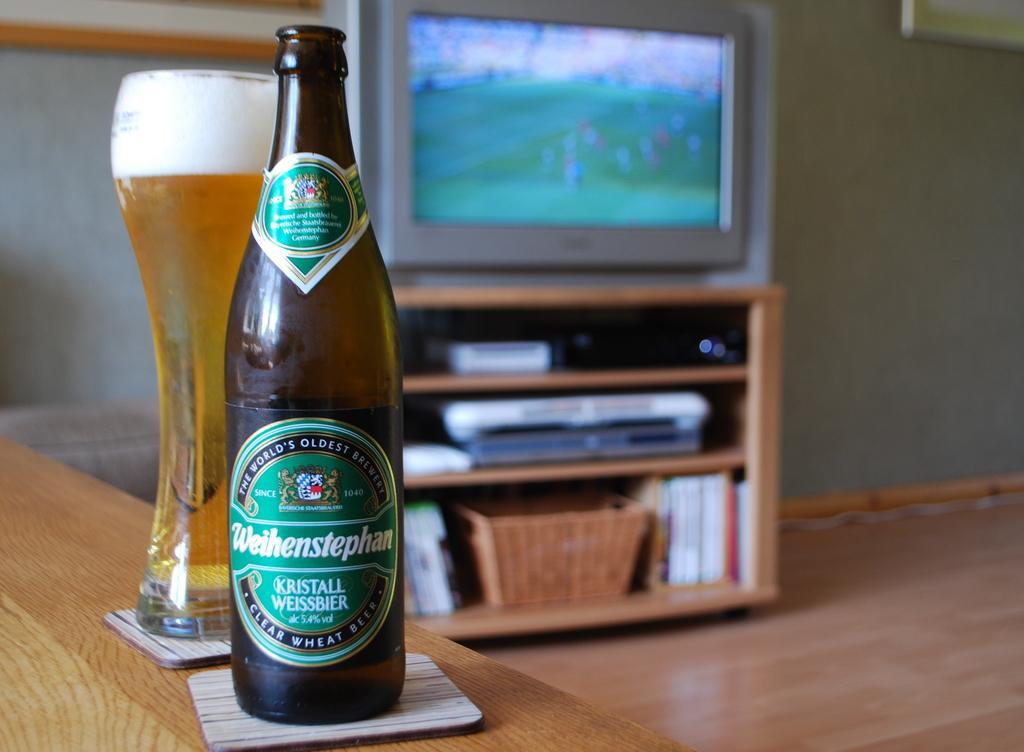<image>
Provide a brief description of the given image. A bottle of beer in front of a glass; the bottle has Clear Wheat Beer on the bottom. 